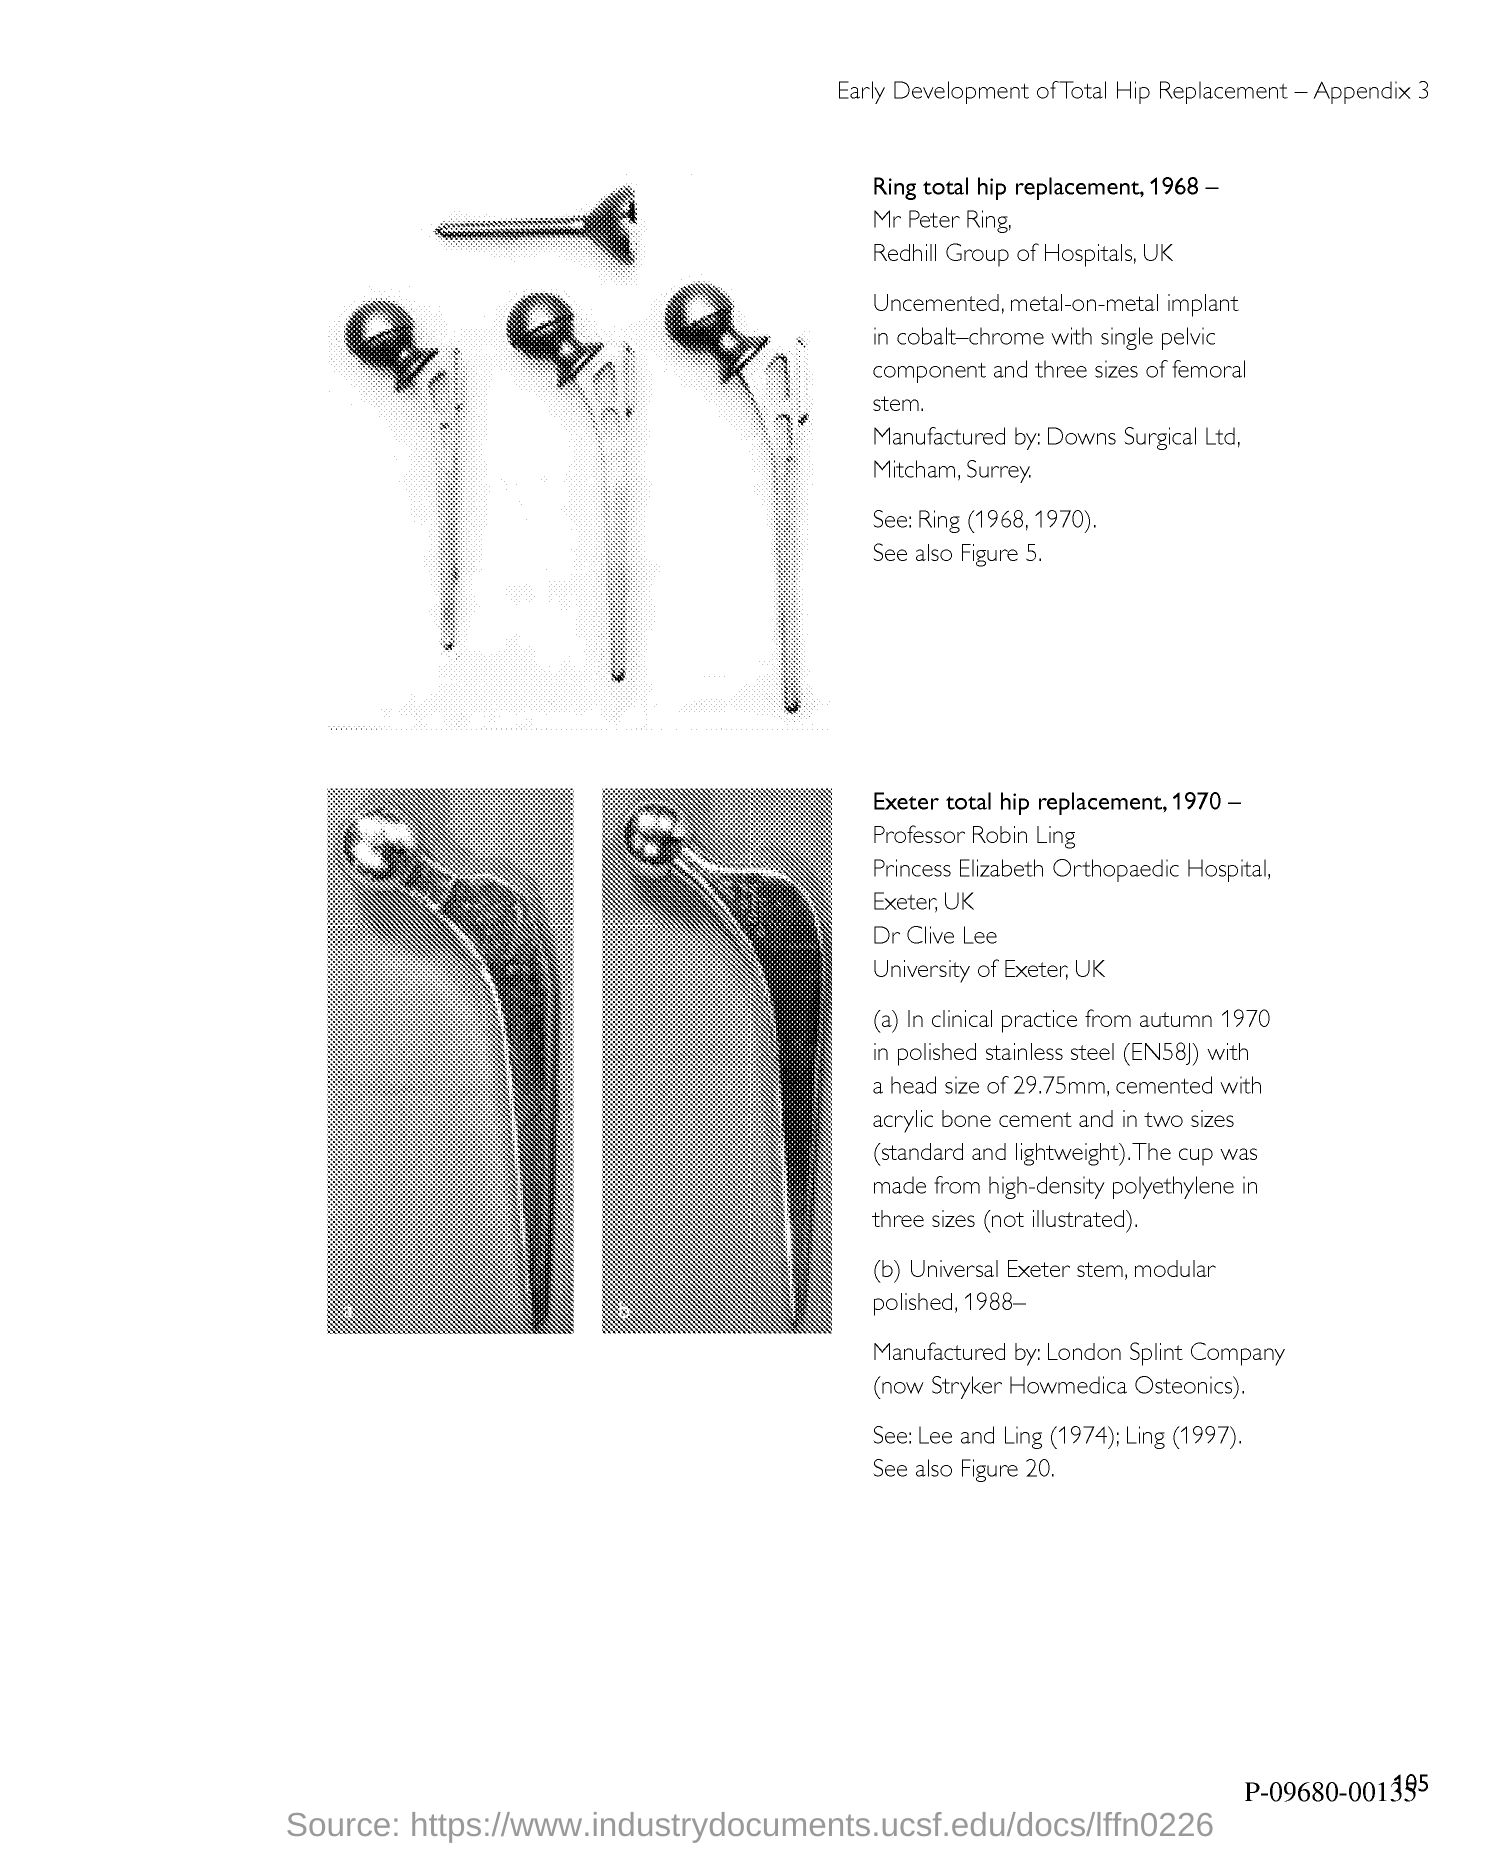Identify some key points in this picture. The page number is 105. 